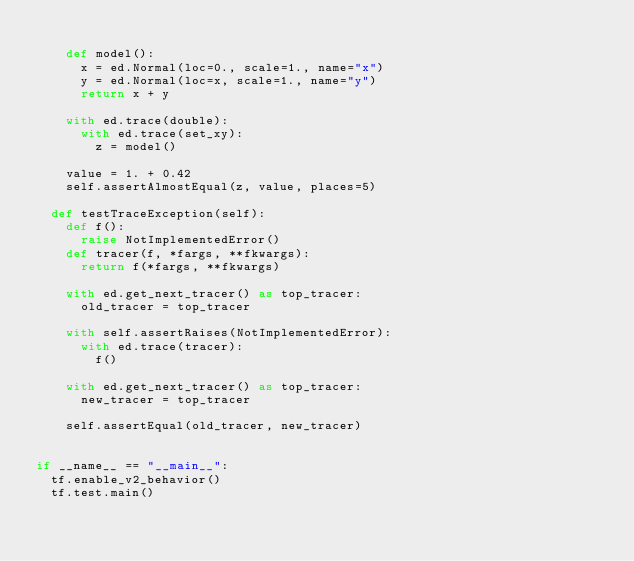<code> <loc_0><loc_0><loc_500><loc_500><_Python_>
    def model():
      x = ed.Normal(loc=0., scale=1., name="x")
      y = ed.Normal(loc=x, scale=1., name="y")
      return x + y

    with ed.trace(double):
      with ed.trace(set_xy):
        z = model()

    value = 1. + 0.42
    self.assertAlmostEqual(z, value, places=5)

  def testTraceException(self):
    def f():
      raise NotImplementedError()
    def tracer(f, *fargs, **fkwargs):
      return f(*fargs, **fkwargs)

    with ed.get_next_tracer() as top_tracer:
      old_tracer = top_tracer

    with self.assertRaises(NotImplementedError):
      with ed.trace(tracer):
        f()

    with ed.get_next_tracer() as top_tracer:
      new_tracer = top_tracer

    self.assertEqual(old_tracer, new_tracer)


if __name__ == "__main__":
  tf.enable_v2_behavior()
  tf.test.main()
</code> 